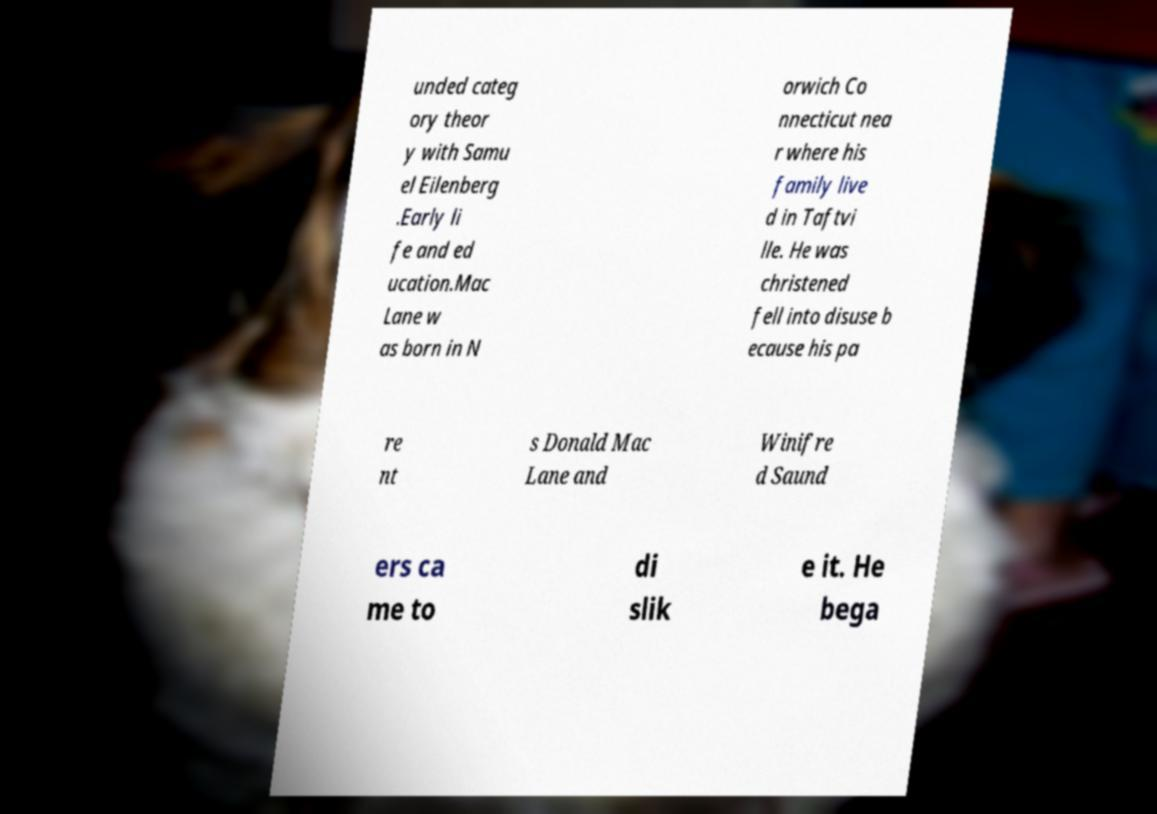For documentation purposes, I need the text within this image transcribed. Could you provide that? unded categ ory theor y with Samu el Eilenberg .Early li fe and ed ucation.Mac Lane w as born in N orwich Co nnecticut nea r where his family live d in Taftvi lle. He was christened fell into disuse b ecause his pa re nt s Donald Mac Lane and Winifre d Saund ers ca me to di slik e it. He bega 